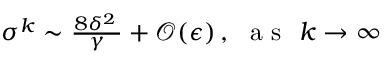<formula> <loc_0><loc_0><loc_500><loc_500>\begin{array} { r } { \sigma ^ { k } \sim \frac { 8 \delta ^ { 2 } \, } { \gamma } + \mathcal { O } ( \epsilon ) \, , a s k \rightarrow \infty } \end{array}</formula> 